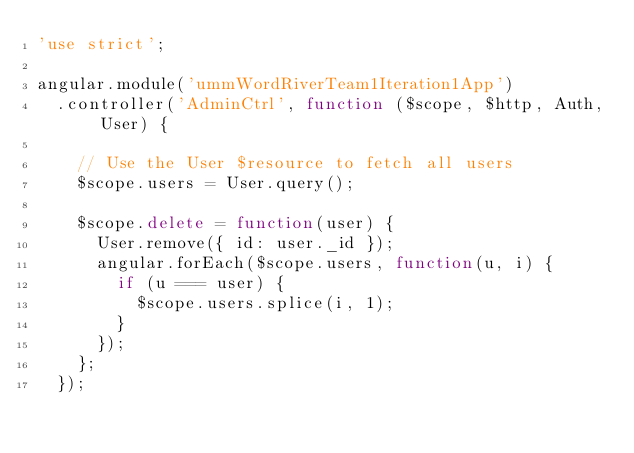Convert code to text. <code><loc_0><loc_0><loc_500><loc_500><_JavaScript_>'use strict';

angular.module('ummWordRiverTeam1Iteration1App')
  .controller('AdminCtrl', function ($scope, $http, Auth, User) {

    // Use the User $resource to fetch all users
    $scope.users = User.query();

    $scope.delete = function(user) {
      User.remove({ id: user._id });
      angular.forEach($scope.users, function(u, i) {
        if (u === user) {
          $scope.users.splice(i, 1);
        }
      });
    };
  });
</code> 